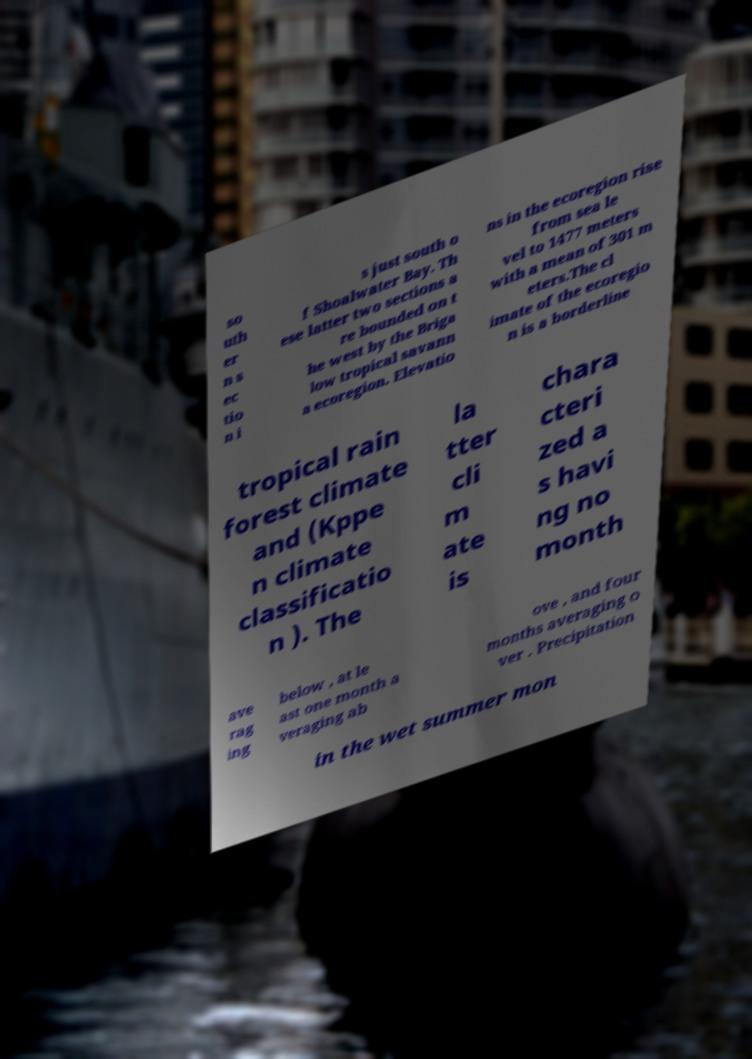There's text embedded in this image that I need extracted. Can you transcribe it verbatim? so uth er n s ec tio n i s just south o f Shoalwater Bay. Th ese latter two sections a re bounded on t he west by the Briga low tropical savann a ecoregion. Elevatio ns in the ecoregion rise from sea le vel to 1477 meters with a mean of 301 m eters.The cl imate of the ecoregio n is a borderline tropical rain forest climate and (Kppe n climate classificatio n ). The la tter cli m ate is chara cteri zed a s havi ng no month ave rag ing below , at le ast one month a veraging ab ove , and four months averaging o ver . Precipitation in the wet summer mon 